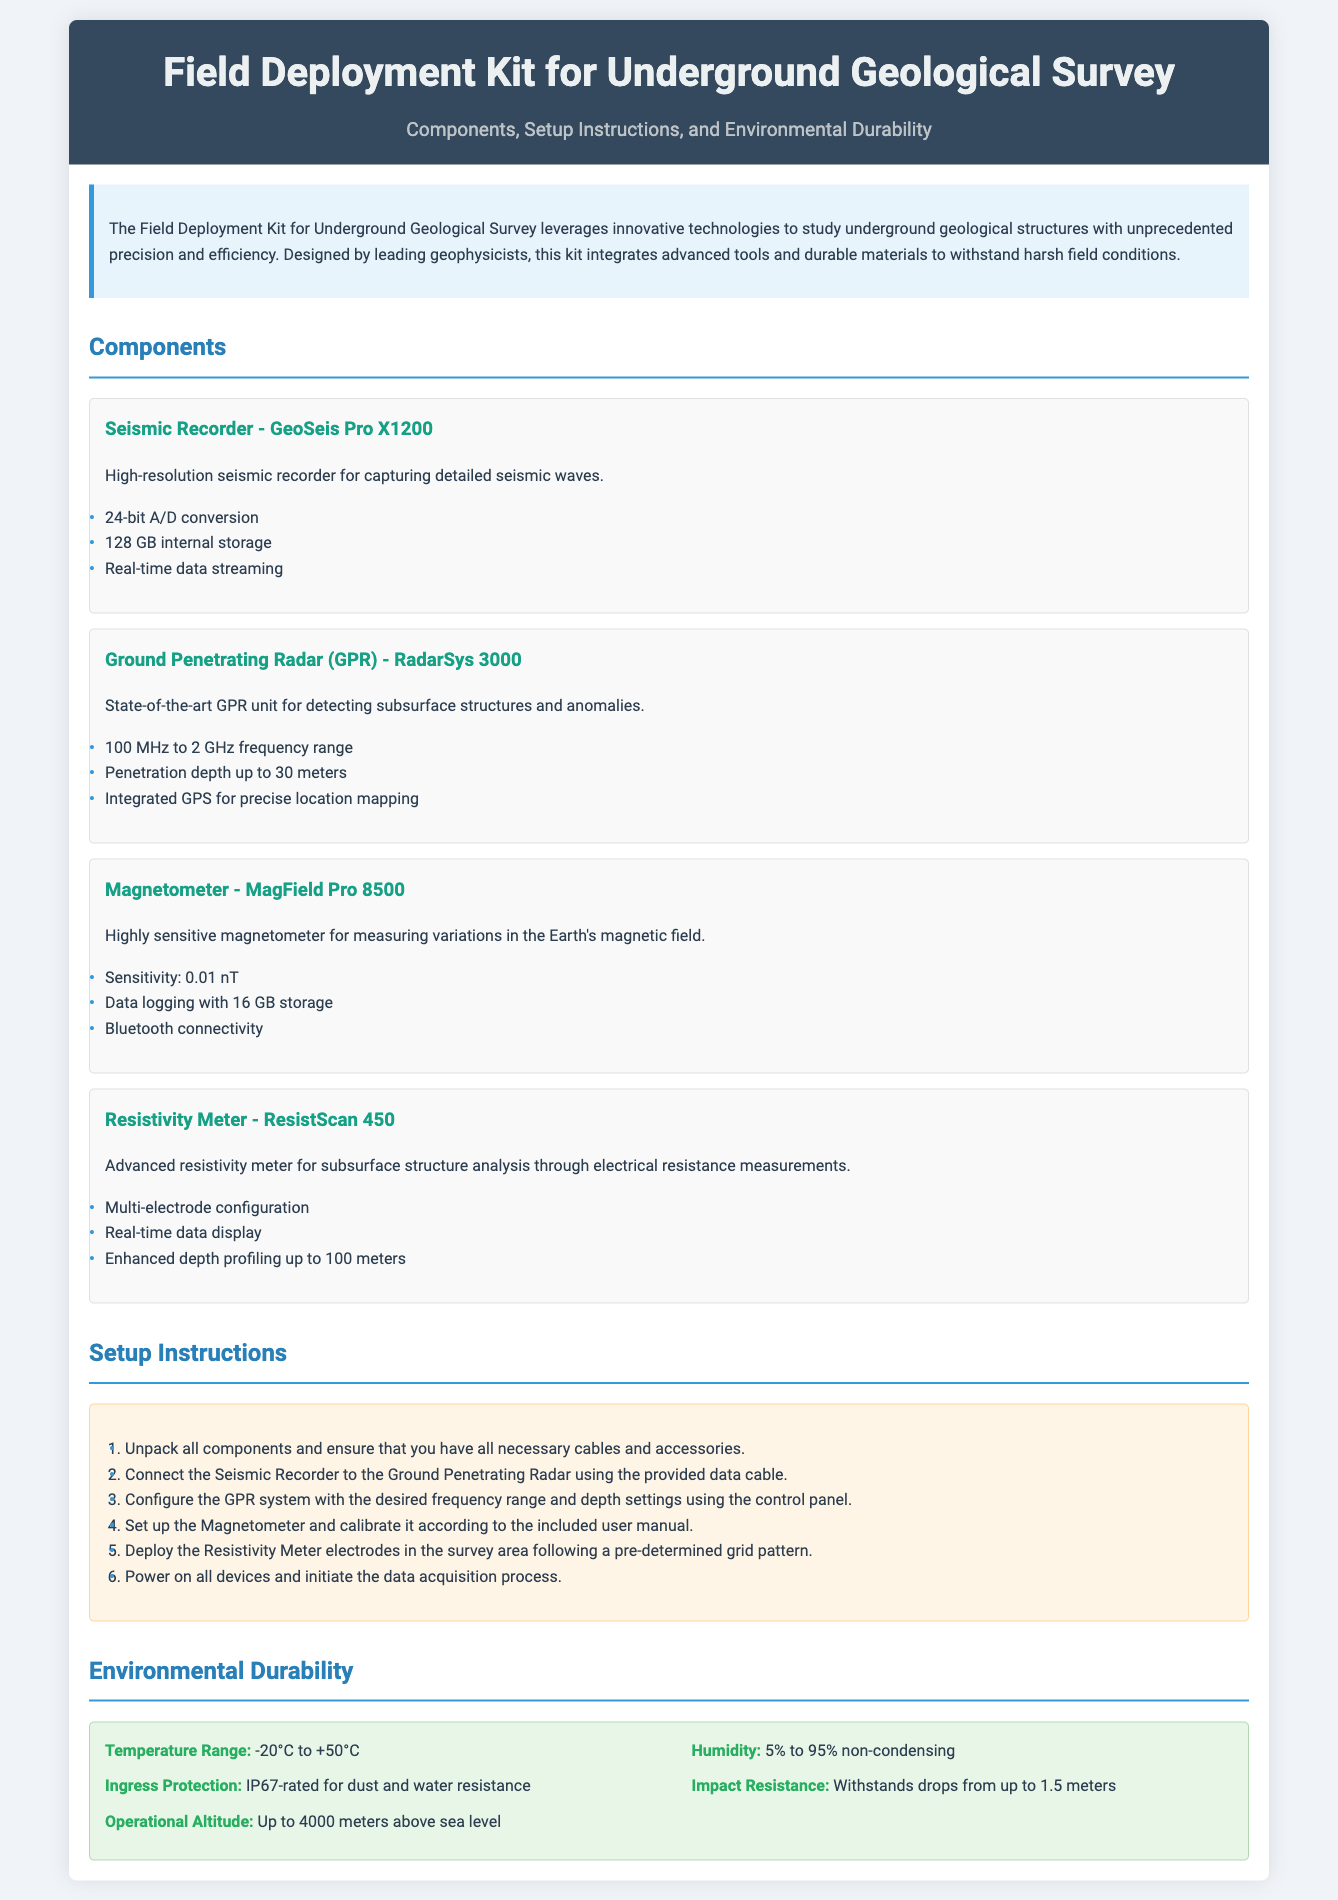What is the name of the seismic recorder? The seismic recorder listed in the document is "GeoSeis Pro X1200".
Answer: GeoSeis Pro X1200 What is the maximum penetration depth of the Ground Penetrating Radar? The Ground Penetrating Radar has a maximum penetration depth of 30 meters.
Answer: 30 meters What is the temperature range for the field deployment kit? The kit is designed to operate within a temperature range of -20°C to +50°C.
Answer: -20°C to +50°C How many bits does the Seismic Recorder use for A/D conversion? The Seismic Recorder uses 24-bit A/D conversion for capturing seismic waves.
Answer: 24-bit What is the total internal storage of the Magnetometer? The Magnetometer comes with 16 GB of internal data logging storage.
Answer: 16 GB What must be done to the Magnetometer before deployment? The Magnetometer must be calibrated according to the included user manual before deployment.
Answer: Calibrated What frequency range is supported by the Ground Penetrating Radar? The Ground Penetrating Radar supports a frequency range of 100 MHz to 2 GHz.
Answer: 100 MHz to 2 GHz What is the Ingress Protection rating of the kit? The kit is rated IP67 for dust and water resistance.
Answer: IP67 How many steps are in the setup instructions? The setup instructions consist of six steps for deployment.
Answer: Six steps 